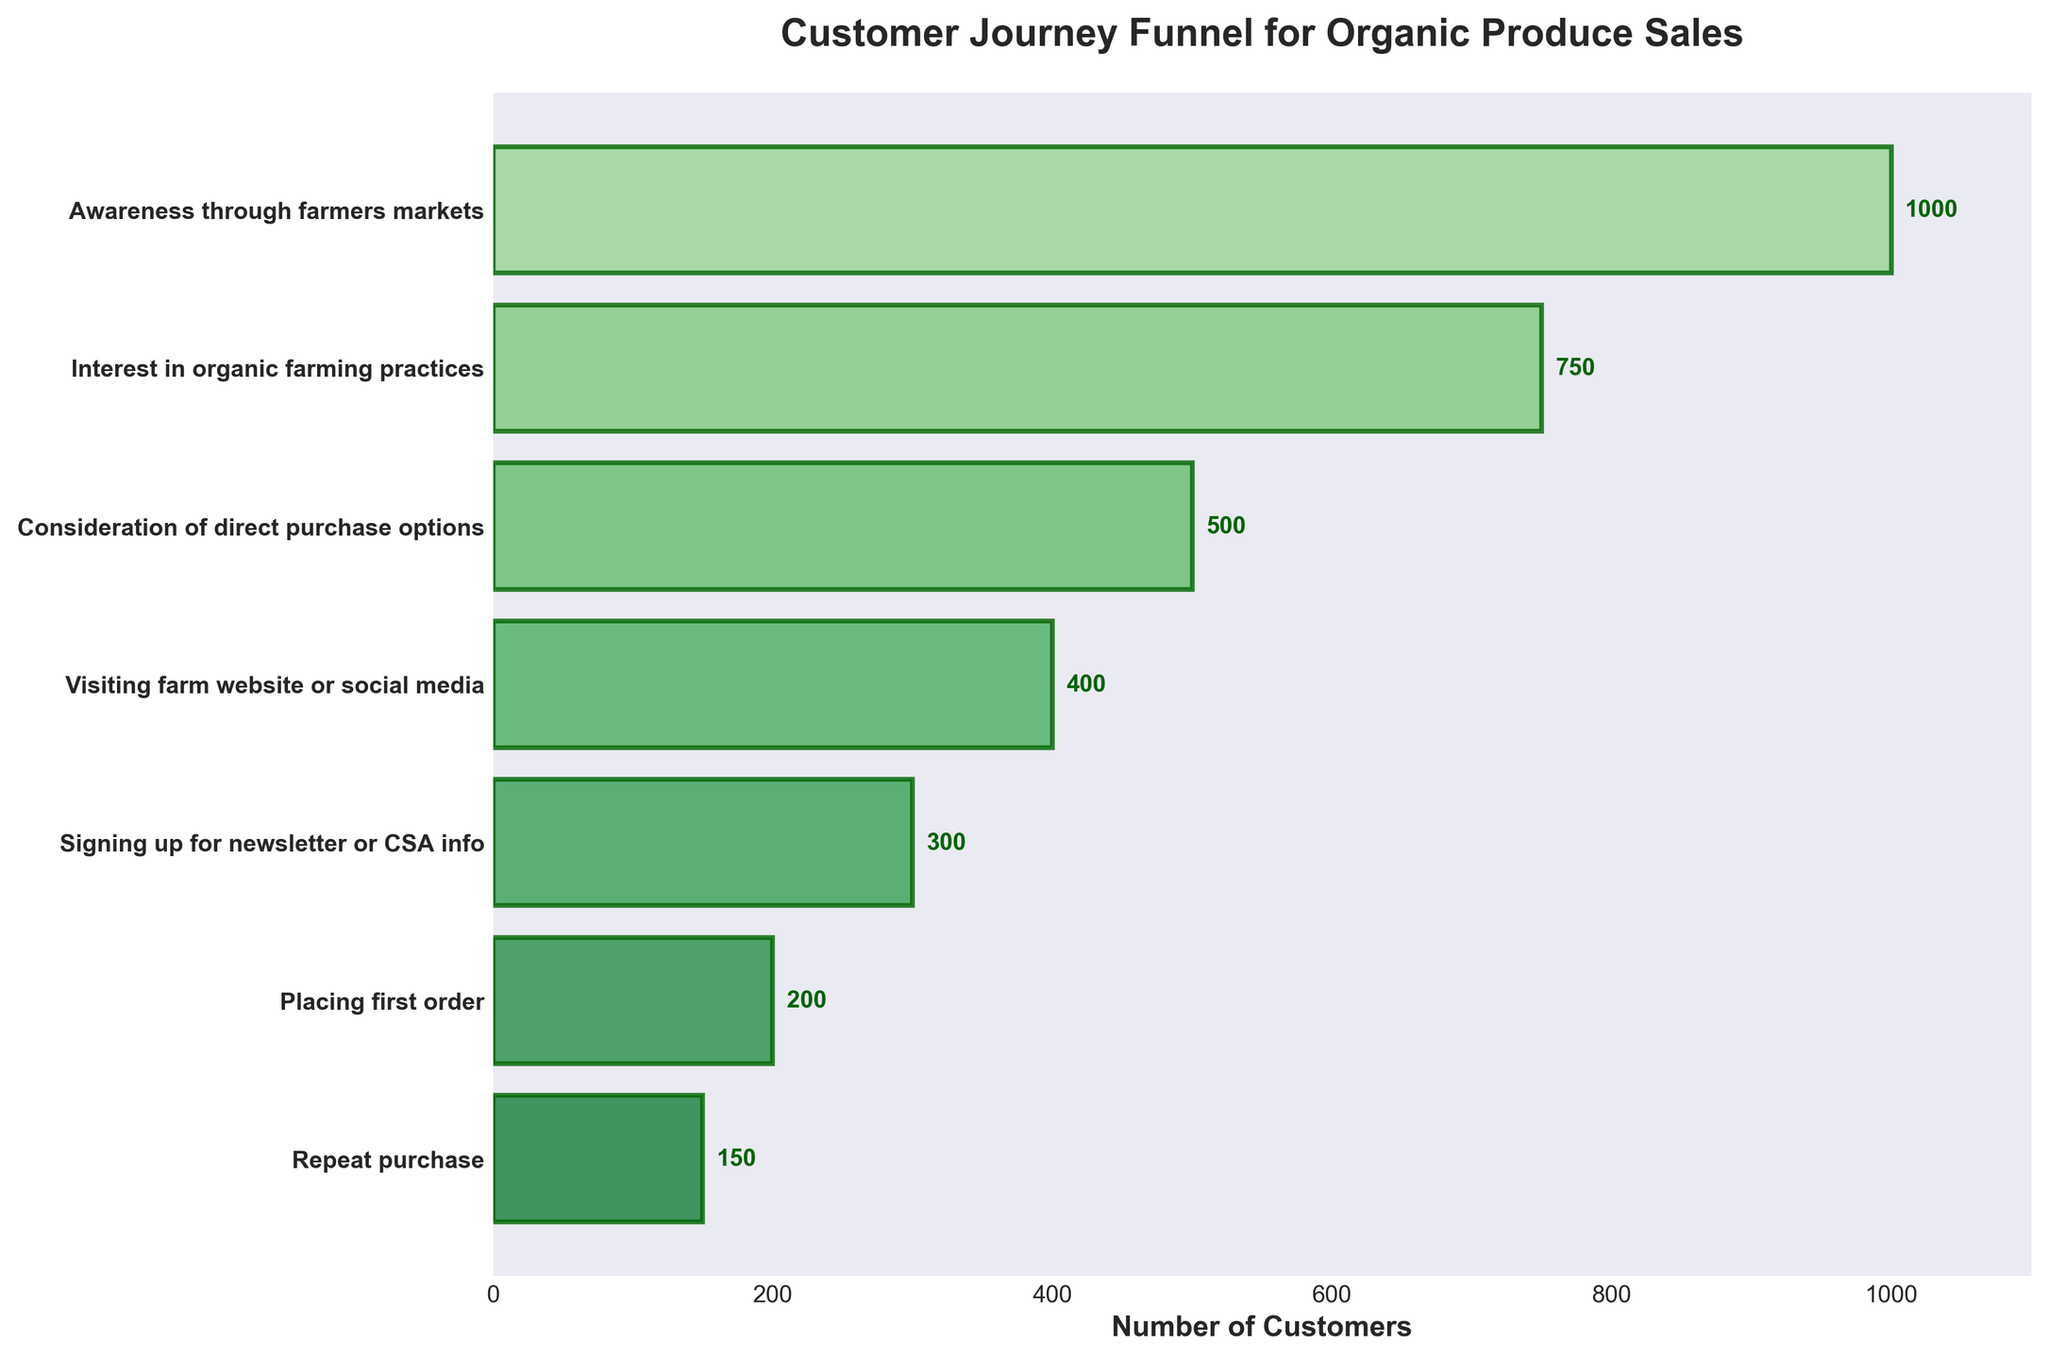What is the title of the figure? The title is written at the top of the chart.
Answer: Customer Journey Funnel for Organic Produce Sales How many customers are at the 'Awareness through farmers markets' stage? Look at the bar labeled 'Awareness through farmers markets' and read the number.
Answer: 1000 Which stage has the fewest number of customers? Compare the lengths of all the bars to find the shortest one. The corresponding stage has the fewest customers.
Answer: Repeat purchase What is the total number of customers from 'Interest in organic farming practices' to 'Placing first order'? Sum the customers from 'Interest in organic farming practices', 'Consideration of direct purchase options', 'Visiting farm website or social media', 'Signing up for newsletter or CSA info', and 'Placing first order'.
Answer: 750 + 500 + 400 + 300 + 200 = 2150 What percentage of customers who visit the farm website or social media sign up for the newsletter or CSA info? Divide the number of customers who signed up for the newsletter or CSA info by the number of customers who visit the website or social media, then multiply by 100.
Answer: (300 / 400) * 100 = 75% What is the difference in the number of customers between 'Placing first order' and 'Repeat purchase'? Subtract the number of customers at 'Repeat purchase' from the number at 'Placing first order'.
Answer: 200 - 150 = 50 Which stage shows the largest drop in the number of customers? Calculate the difference between each consecutive pair of stages and identify the largest difference.
Answer: Awareness through farmers markets to Interest in organic farming practices (1000 - 750 = 250) What is the total decline in the number of customers from 'Awareness through farmers markets' to 'Repeat purchase'? Subtract the number of customers at 'Repeat purchase' from the number at 'Awareness through farmers markets'.
Answer: 1000 - 150 = 850 How does the number of customers change from 'Consideration of direct purchase options' to 'Visiting farm website or social media'? Compare the number of customers at both stages to determine if there is an increase or decrease.
Answer: Decrease (500 to 400) What is the average number of customers across all stages? Sum the numbers of customers for all stages and divide by the number of stages.
Answer: (1000 + 750 + 500 + 400 + 300 + 200 + 150) / 7 = 471.43 